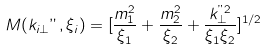<formula> <loc_0><loc_0><loc_500><loc_500>M ( { k } _ { i \bot } " , \xi _ { i } ) = [ \frac { m _ { 1 } ^ { 2 } } { \xi _ { 1 } } + \frac { m _ { 2 } ^ { 2 } } { \xi _ { 2 } } + \frac { { k } _ { \bot } ^ { " 2 } } { \xi _ { 1 } \xi _ { 2 } } ] ^ { 1 / 2 }</formula> 